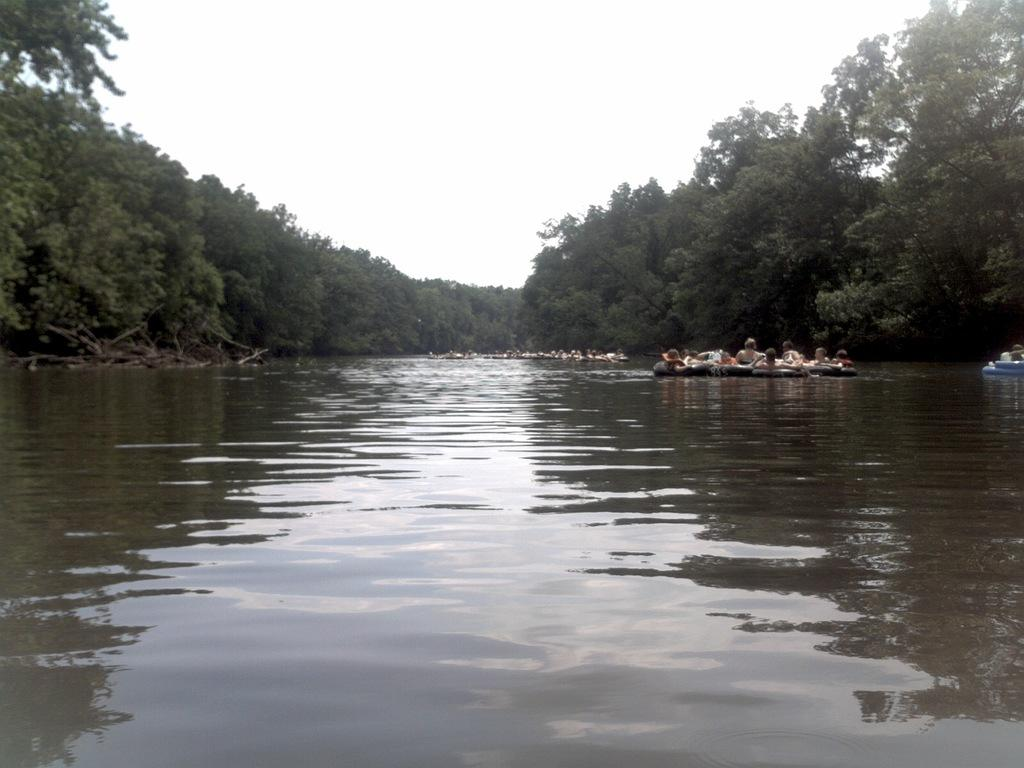What type of natural feature is present in the image? There is a river in the image. What are the people in the image doing? There are persons in a boat in the image. What can be seen in the background of the image? There are trees visible in the background of the image. What type of metal can be seen in the image? There is no metal present in the image. How many birds are in the flock in the image? There is no flock of birds present in the image. 